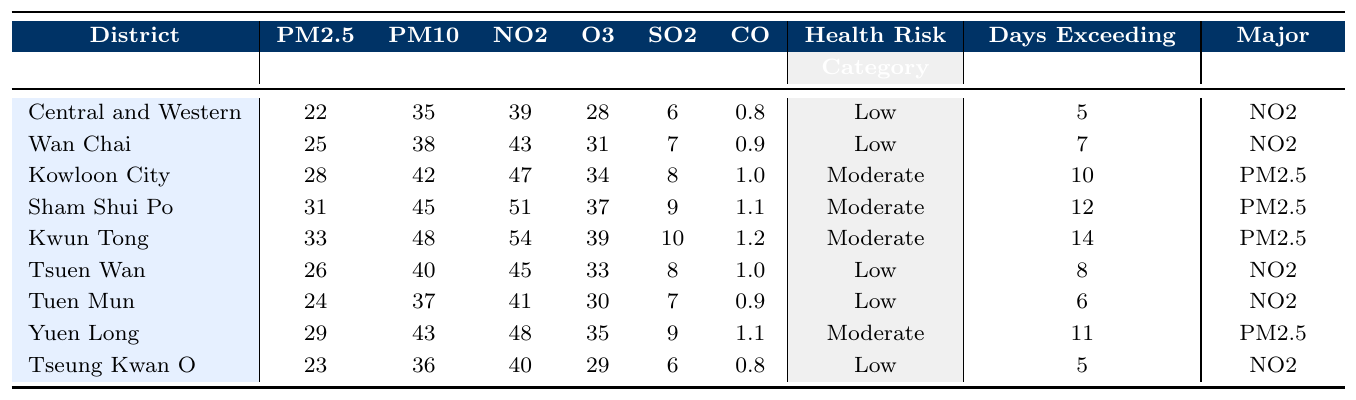What is the Health Risk Category for Kowloon City? The Health Risk Category for Kowloon City is listed in the table under that district, which shows "Moderate."
Answer: Moderate Which district has the highest PM10 level? By examining the PM10 values for each district, Kwun Tong has the highest PM10 level of 48.
Answer: Kwun Tong How many days in total exceeded WHO guidelines for all districts? Adding the days exceeding WHO guidelines: 5 + 7 + 10 + 12 + 14 + 8 + 6 + 11 + 5 = 68.
Answer: 68 Is Central and Western district categorized as Low or Moderate health risk? The table indicates that Central and Western district is categorized as "Low."
Answer: Low What is the average level of NO2 across all districts? The NO2 levels are: 39, 43, 47, 51, 54, 45, 41, 48, 40. Adding these gives 408, and there are 9 districts, so the average is 408/9 = 45.33.
Answer: 45.33 Which district has the major pollutant as PM2.5 and how many days exceeded WHO guidelines? In the table, Kowloon City and Sham Shui Po have PM2.5 as their major pollutant, with days exceeding WHO guidelines being 10 and 12 respectively.
Answer: Kowloon City: 10 days, Sham Shui Po: 12 days What is the difference in PM2.5 levels between the district with the highest and lowest PM2.5? The highest PM2.5 level is in Kwun Tong (33), and the lowest is in Central and Western (22). The difference is 33 - 22 = 11.
Answer: 11 Which two districts had the most days exceeding WHO guidelines? From the table, Kwun Tong had 14 days and Sham Shui Po had 12 days, making them the two districts with the most.
Answer: Kwun Tong and Sham Shui Po Is the major pollutant for Yuen Long the same as the one for Sham Shui Po? Yuen Long's major pollutant is PM2.5 while Sham Shui Po's is also PM2.5, indicating they are the same.
Answer: Yes Which district has the lowest SO2 level, and what is that level? The table shows that Central and Western and Tseung Kwan O both have the lowest SO2 level of 6.
Answer: 6 